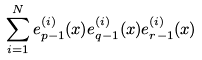Convert formula to latex. <formula><loc_0><loc_0><loc_500><loc_500>\sum _ { i = 1 } ^ { N } e _ { p - 1 } ^ { ( i ) } ( x ) e _ { q - 1 } ^ { ( i ) } ( x ) e _ { r - 1 } ^ { ( i ) } ( x )</formula> 